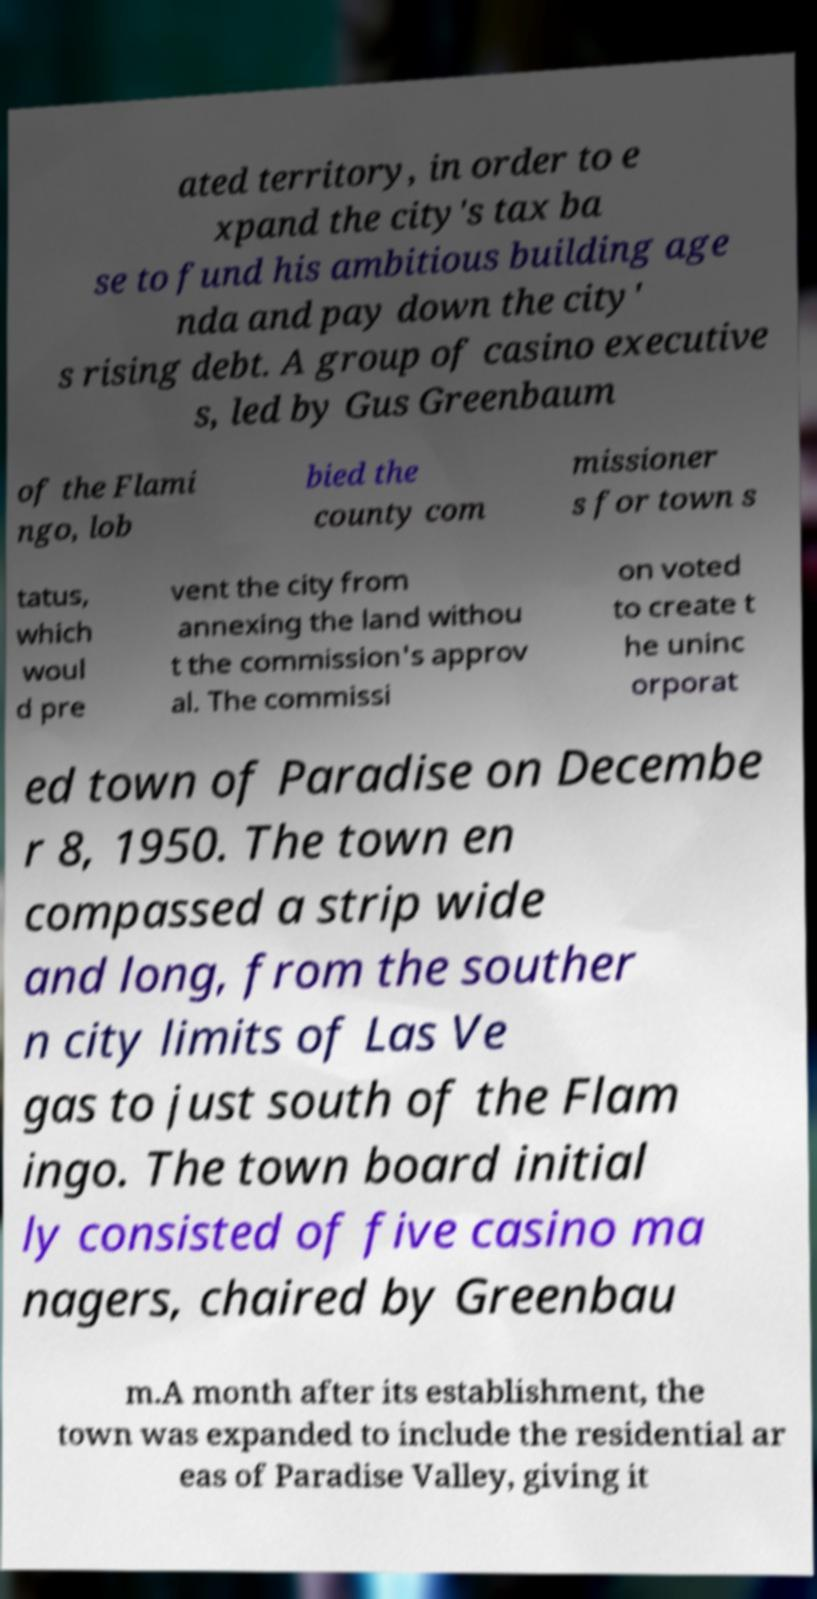Please identify and transcribe the text found in this image. ated territory, in order to e xpand the city's tax ba se to fund his ambitious building age nda and pay down the city' s rising debt. A group of casino executive s, led by Gus Greenbaum of the Flami ngo, lob bied the county com missioner s for town s tatus, which woul d pre vent the city from annexing the land withou t the commission's approv al. The commissi on voted to create t he uninc orporat ed town of Paradise on Decembe r 8, 1950. The town en compassed a strip wide and long, from the souther n city limits of Las Ve gas to just south of the Flam ingo. The town board initial ly consisted of five casino ma nagers, chaired by Greenbau m.A month after its establishment, the town was expanded to include the residential ar eas of Paradise Valley, giving it 